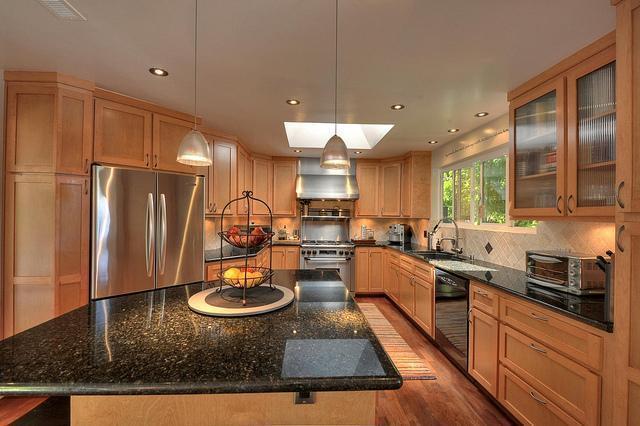What is the countertop in the middle called?
From the following set of four choices, select the accurate answer to respond to the question.
Options: Bar, cart, island, kitchen table. Island. 